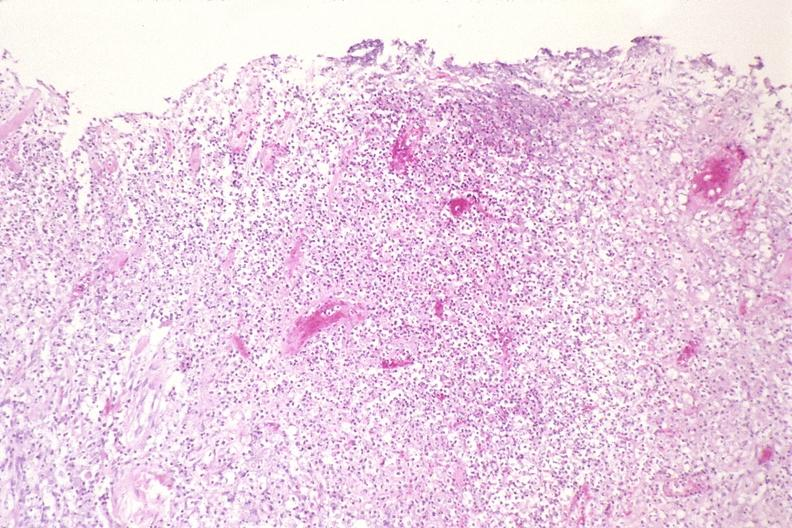s respiratory present?
Answer the question using a single word or phrase. Yes 